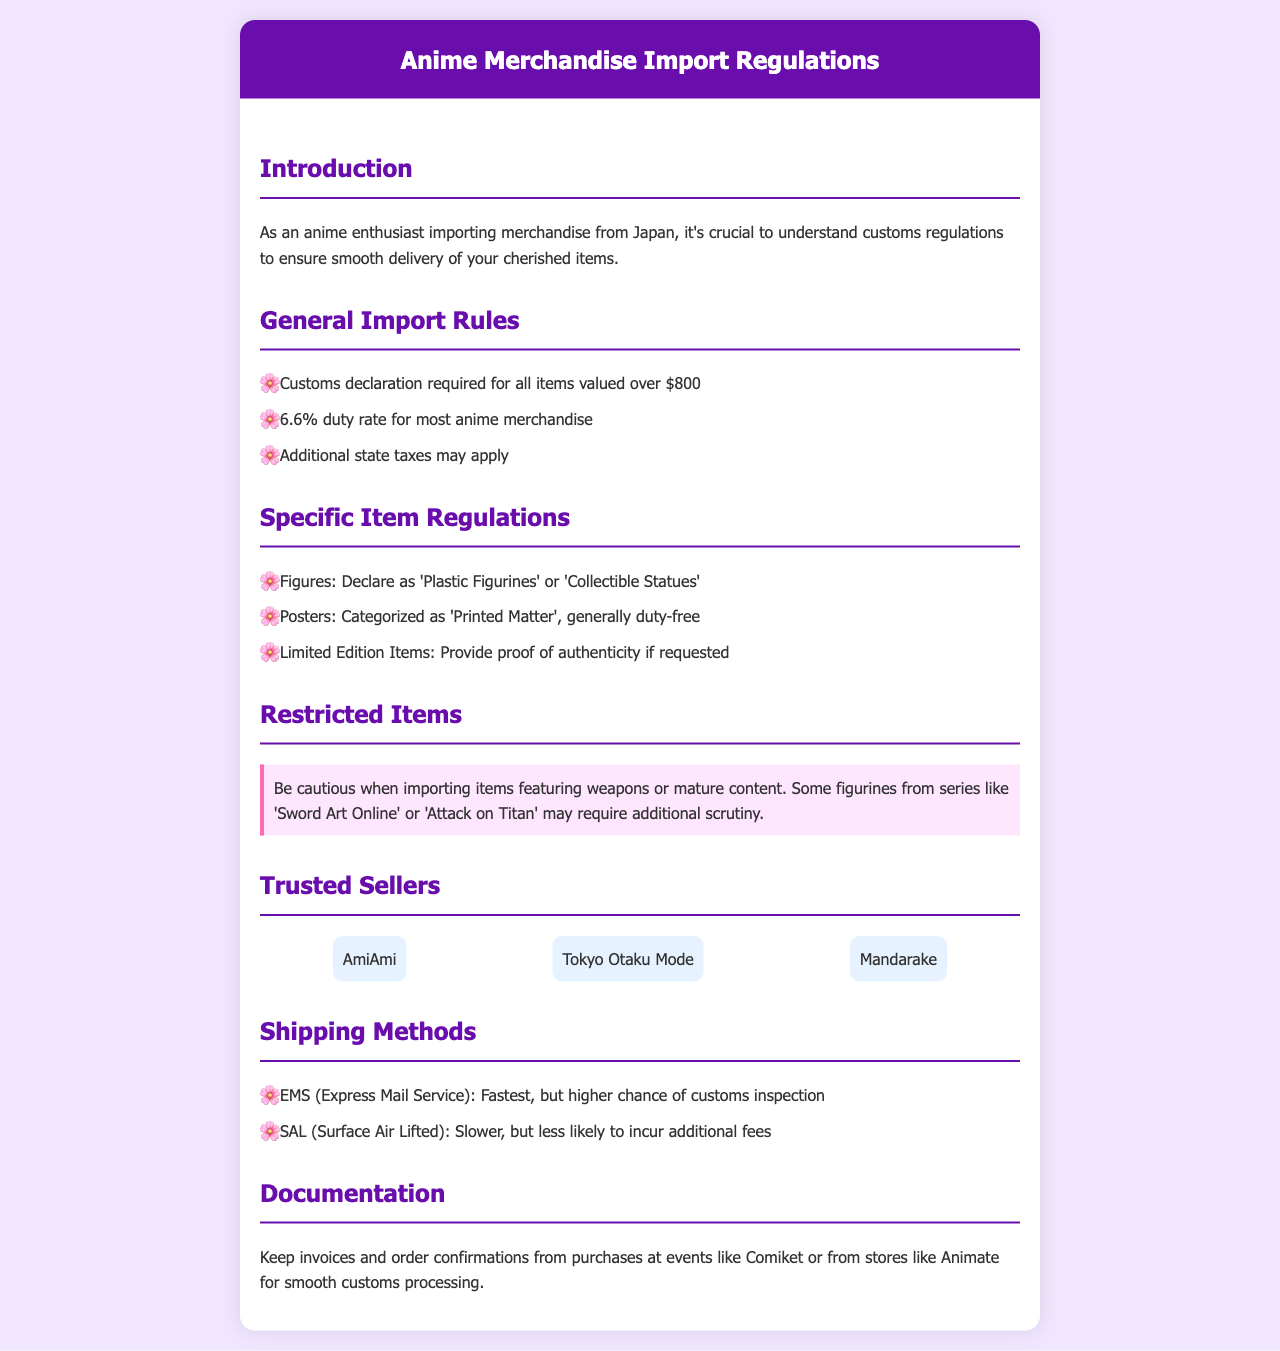What is the duty rate for most anime merchandise? The document states that the duty rate for most anime merchandise is 6.6%.
Answer: 6.6% What do you declare figures as? The document specifies that figures should be declared as 'Plastic Figurines' or 'Collectible Statues'.
Answer: Plastic Figurines or Collectible Statues What type of items are generally duty-free? The document categorizes posters as 'Printed Matter', which is generally duty-free.
Answer: Printed Matter What is the maximum value for items to not require a customs declaration? The document mentions that customs declaration is required for all items valued over $800.
Answer: $800 Which shipping method is the fastest? The document indicates that EMS (Express Mail Service) is the fastest shipping method.
Answer: EMS What is a restriction mentioned for importing items? The document highlights that caution is needed when importing items featuring weapons or mature content.
Answer: Weapons or mature content Who are the trusted sellers listed in the document? The document lists AmiAmi, Tokyo Otaku Mode, and Mandarake as trusted sellers.
Answer: AmiAmi, Tokyo Otaku Mode, Mandarake What should be kept for smooth customs processing? The document advises keeping invoices and order confirmations from purchases for smooth customs processing.
Answer: Invoices and order confirmations 